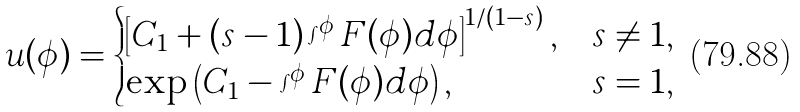Convert formula to latex. <formula><loc_0><loc_0><loc_500><loc_500>u ( \phi ) = \begin{cases} \left [ C _ { 1 } + \left ( s - 1 \right ) \int ^ { \phi } F ( \phi ) d \phi \right ] ^ { 1 / ( 1 - s ) } , & s \neq 1 , \\ \exp \left ( C _ { 1 } - \int ^ { \phi } F ( \phi ) d \phi \right ) , & s = 1 , \end{cases}</formula> 